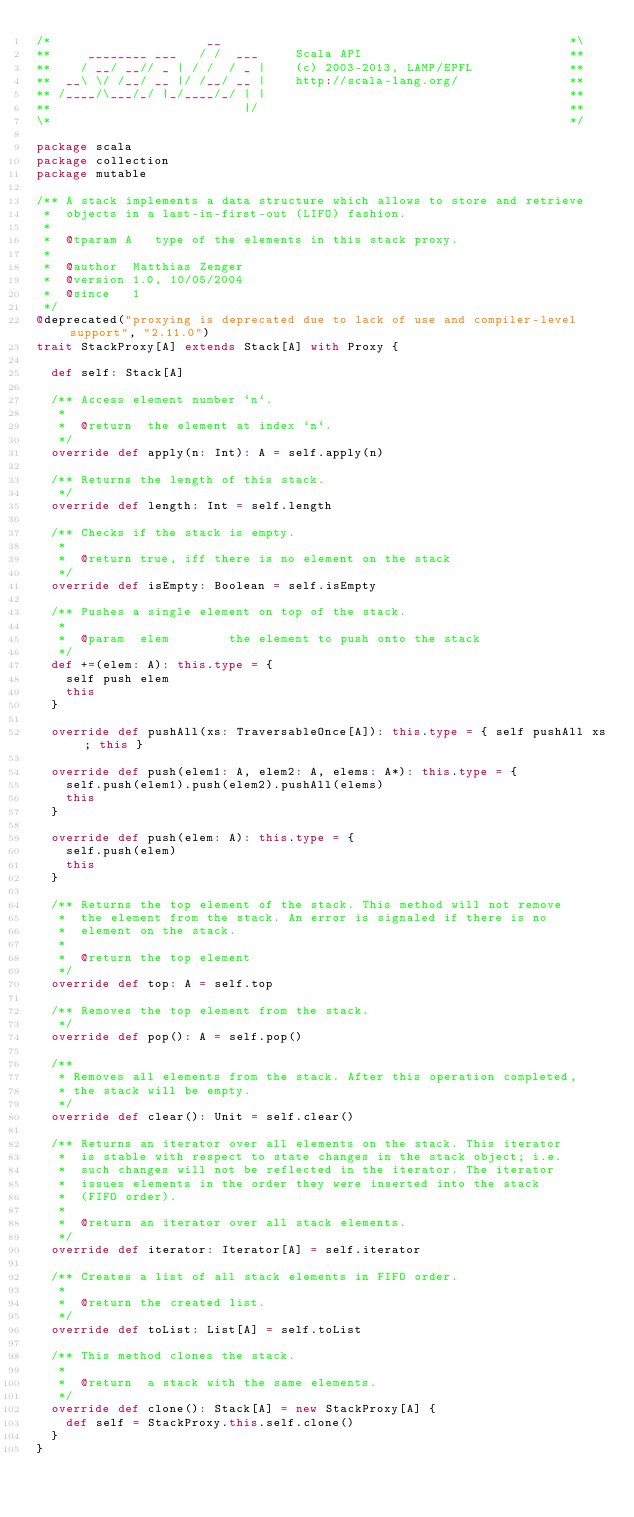Convert code to text. <code><loc_0><loc_0><loc_500><loc_500><_Scala_>/*                     __                                               *\
**     ________ ___   / /  ___     Scala API                            **
**    / __/ __// _ | / /  / _ |    (c) 2003-2013, LAMP/EPFL             **
**  __\ \/ /__/ __ |/ /__/ __ |    http://scala-lang.org/               **
** /____/\___/_/ |_/____/_/ | |                                         **
**                          |/                                          **
\*                                                                      */

package scala
package collection
package mutable

/** A stack implements a data structure which allows to store and retrieve
 *  objects in a last-in-first-out (LIFO) fashion.
 *
 *  @tparam A   type of the elements in this stack proxy.
 *
 *  @author  Matthias Zenger
 *  @version 1.0, 10/05/2004
 *  @since   1
 */
@deprecated("proxying is deprecated due to lack of use and compiler-level support", "2.11.0")
trait StackProxy[A] extends Stack[A] with Proxy {

  def self: Stack[A]

  /** Access element number `n`.
   *
   *  @return  the element at index `n`.
   */
  override def apply(n: Int): A = self.apply(n)

  /** Returns the length of this stack.
   */
  override def length: Int = self.length

  /** Checks if the stack is empty.
   *
   *  @return true, iff there is no element on the stack
   */
  override def isEmpty: Boolean = self.isEmpty

  /** Pushes a single element on top of the stack.
   *
   *  @param  elem        the element to push onto the stack
   */
  def +=(elem: A): this.type = {
    self push elem
    this
  }

  override def pushAll(xs: TraversableOnce[A]): this.type = { self pushAll xs; this }

  override def push(elem1: A, elem2: A, elems: A*): this.type = {
    self.push(elem1).push(elem2).pushAll(elems)
    this
  }

  override def push(elem: A): this.type = {
    self.push(elem)
    this
  }

  /** Returns the top element of the stack. This method will not remove
   *  the element from the stack. An error is signaled if there is no
   *  element on the stack.
   *
   *  @return the top element
   */
  override def top: A = self.top

  /** Removes the top element from the stack.
   */
  override def pop(): A = self.pop()

  /**
   * Removes all elements from the stack. After this operation completed,
   * the stack will be empty.
   */
  override def clear(): Unit = self.clear()

  /** Returns an iterator over all elements on the stack. This iterator
   *  is stable with respect to state changes in the stack object; i.e.
   *  such changes will not be reflected in the iterator. The iterator
   *  issues elements in the order they were inserted into the stack
   *  (FIFO order).
   *
   *  @return an iterator over all stack elements.
   */
  override def iterator: Iterator[A] = self.iterator

  /** Creates a list of all stack elements in FIFO order.
   *
   *  @return the created list.
   */
  override def toList: List[A] = self.toList

  /** This method clones the stack.
   *
   *  @return  a stack with the same elements.
   */
  override def clone(): Stack[A] = new StackProxy[A] {
    def self = StackProxy.this.self.clone()
  }
}
</code> 